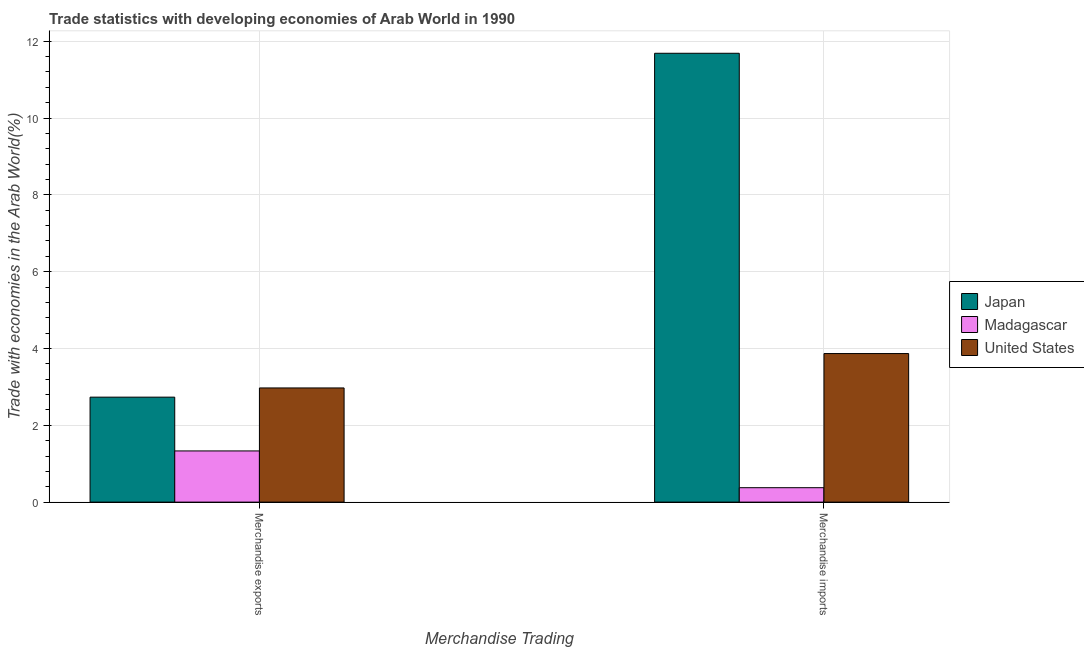How many different coloured bars are there?
Provide a succinct answer. 3. How many groups of bars are there?
Give a very brief answer. 2. Are the number of bars on each tick of the X-axis equal?
Make the answer very short. Yes. How many bars are there on the 1st tick from the left?
Provide a succinct answer. 3. How many bars are there on the 2nd tick from the right?
Provide a succinct answer. 3. What is the merchandise exports in Japan?
Your response must be concise. 2.73. Across all countries, what is the maximum merchandise exports?
Make the answer very short. 2.97. Across all countries, what is the minimum merchandise exports?
Provide a short and direct response. 1.33. In which country was the merchandise exports maximum?
Your answer should be very brief. United States. In which country was the merchandise imports minimum?
Provide a short and direct response. Madagascar. What is the total merchandise imports in the graph?
Your answer should be very brief. 15.93. What is the difference between the merchandise exports in Japan and that in Madagascar?
Your answer should be compact. 1.4. What is the difference between the merchandise exports in Madagascar and the merchandise imports in Japan?
Offer a very short reply. -10.35. What is the average merchandise imports per country?
Make the answer very short. 5.31. What is the difference between the merchandise exports and merchandise imports in Japan?
Provide a succinct answer. -8.95. What is the ratio of the merchandise imports in Japan to that in United States?
Provide a short and direct response. 3.02. Is the merchandise exports in Japan less than that in Madagascar?
Offer a terse response. No. What does the 2nd bar from the right in Merchandise imports represents?
Offer a terse response. Madagascar. How many bars are there?
Make the answer very short. 6. Are all the bars in the graph horizontal?
Your answer should be compact. No. What is the difference between two consecutive major ticks on the Y-axis?
Your answer should be compact. 2. Are the values on the major ticks of Y-axis written in scientific E-notation?
Keep it short and to the point. No. Does the graph contain grids?
Offer a very short reply. Yes. What is the title of the graph?
Your response must be concise. Trade statistics with developing economies of Arab World in 1990. What is the label or title of the X-axis?
Your answer should be compact. Merchandise Trading. What is the label or title of the Y-axis?
Offer a terse response. Trade with economies in the Arab World(%). What is the Trade with economies in the Arab World(%) of Japan in Merchandise exports?
Offer a very short reply. 2.73. What is the Trade with economies in the Arab World(%) of Madagascar in Merchandise exports?
Make the answer very short. 1.33. What is the Trade with economies in the Arab World(%) in United States in Merchandise exports?
Provide a short and direct response. 2.97. What is the Trade with economies in the Arab World(%) of Japan in Merchandise imports?
Provide a succinct answer. 11.69. What is the Trade with economies in the Arab World(%) in Madagascar in Merchandise imports?
Make the answer very short. 0.38. What is the Trade with economies in the Arab World(%) of United States in Merchandise imports?
Offer a terse response. 3.87. Across all Merchandise Trading, what is the maximum Trade with economies in the Arab World(%) in Japan?
Give a very brief answer. 11.69. Across all Merchandise Trading, what is the maximum Trade with economies in the Arab World(%) of Madagascar?
Your answer should be compact. 1.33. Across all Merchandise Trading, what is the maximum Trade with economies in the Arab World(%) in United States?
Keep it short and to the point. 3.87. Across all Merchandise Trading, what is the minimum Trade with economies in the Arab World(%) in Japan?
Give a very brief answer. 2.73. Across all Merchandise Trading, what is the minimum Trade with economies in the Arab World(%) in Madagascar?
Give a very brief answer. 0.38. Across all Merchandise Trading, what is the minimum Trade with economies in the Arab World(%) of United States?
Your response must be concise. 2.97. What is the total Trade with economies in the Arab World(%) of Japan in the graph?
Keep it short and to the point. 14.42. What is the total Trade with economies in the Arab World(%) of Madagascar in the graph?
Your response must be concise. 1.71. What is the total Trade with economies in the Arab World(%) of United States in the graph?
Provide a short and direct response. 6.84. What is the difference between the Trade with economies in the Arab World(%) in Japan in Merchandise exports and that in Merchandise imports?
Offer a terse response. -8.95. What is the difference between the Trade with economies in the Arab World(%) of Madagascar in Merchandise exports and that in Merchandise imports?
Your answer should be very brief. 0.96. What is the difference between the Trade with economies in the Arab World(%) in United States in Merchandise exports and that in Merchandise imports?
Give a very brief answer. -0.9. What is the difference between the Trade with economies in the Arab World(%) of Japan in Merchandise exports and the Trade with economies in the Arab World(%) of Madagascar in Merchandise imports?
Make the answer very short. 2.36. What is the difference between the Trade with economies in the Arab World(%) of Japan in Merchandise exports and the Trade with economies in the Arab World(%) of United States in Merchandise imports?
Give a very brief answer. -1.13. What is the difference between the Trade with economies in the Arab World(%) in Madagascar in Merchandise exports and the Trade with economies in the Arab World(%) in United States in Merchandise imports?
Keep it short and to the point. -2.54. What is the average Trade with economies in the Arab World(%) of Japan per Merchandise Trading?
Give a very brief answer. 7.21. What is the average Trade with economies in the Arab World(%) of Madagascar per Merchandise Trading?
Your answer should be very brief. 0.85. What is the average Trade with economies in the Arab World(%) of United States per Merchandise Trading?
Offer a very short reply. 3.42. What is the difference between the Trade with economies in the Arab World(%) of Japan and Trade with economies in the Arab World(%) of Madagascar in Merchandise exports?
Give a very brief answer. 1.4. What is the difference between the Trade with economies in the Arab World(%) of Japan and Trade with economies in the Arab World(%) of United States in Merchandise exports?
Ensure brevity in your answer.  -0.24. What is the difference between the Trade with economies in the Arab World(%) of Madagascar and Trade with economies in the Arab World(%) of United States in Merchandise exports?
Your response must be concise. -1.64. What is the difference between the Trade with economies in the Arab World(%) in Japan and Trade with economies in the Arab World(%) in Madagascar in Merchandise imports?
Your answer should be compact. 11.31. What is the difference between the Trade with economies in the Arab World(%) in Japan and Trade with economies in the Arab World(%) in United States in Merchandise imports?
Offer a very short reply. 7.82. What is the difference between the Trade with economies in the Arab World(%) of Madagascar and Trade with economies in the Arab World(%) of United States in Merchandise imports?
Keep it short and to the point. -3.49. What is the ratio of the Trade with economies in the Arab World(%) in Japan in Merchandise exports to that in Merchandise imports?
Ensure brevity in your answer.  0.23. What is the ratio of the Trade with economies in the Arab World(%) in Madagascar in Merchandise exports to that in Merchandise imports?
Provide a succinct answer. 3.55. What is the ratio of the Trade with economies in the Arab World(%) in United States in Merchandise exports to that in Merchandise imports?
Give a very brief answer. 0.77. What is the difference between the highest and the second highest Trade with economies in the Arab World(%) of Japan?
Your answer should be compact. 8.95. What is the difference between the highest and the second highest Trade with economies in the Arab World(%) of Madagascar?
Keep it short and to the point. 0.96. What is the difference between the highest and the second highest Trade with economies in the Arab World(%) of United States?
Give a very brief answer. 0.9. What is the difference between the highest and the lowest Trade with economies in the Arab World(%) of Japan?
Provide a succinct answer. 8.95. What is the difference between the highest and the lowest Trade with economies in the Arab World(%) of Madagascar?
Your response must be concise. 0.96. What is the difference between the highest and the lowest Trade with economies in the Arab World(%) in United States?
Offer a very short reply. 0.9. 